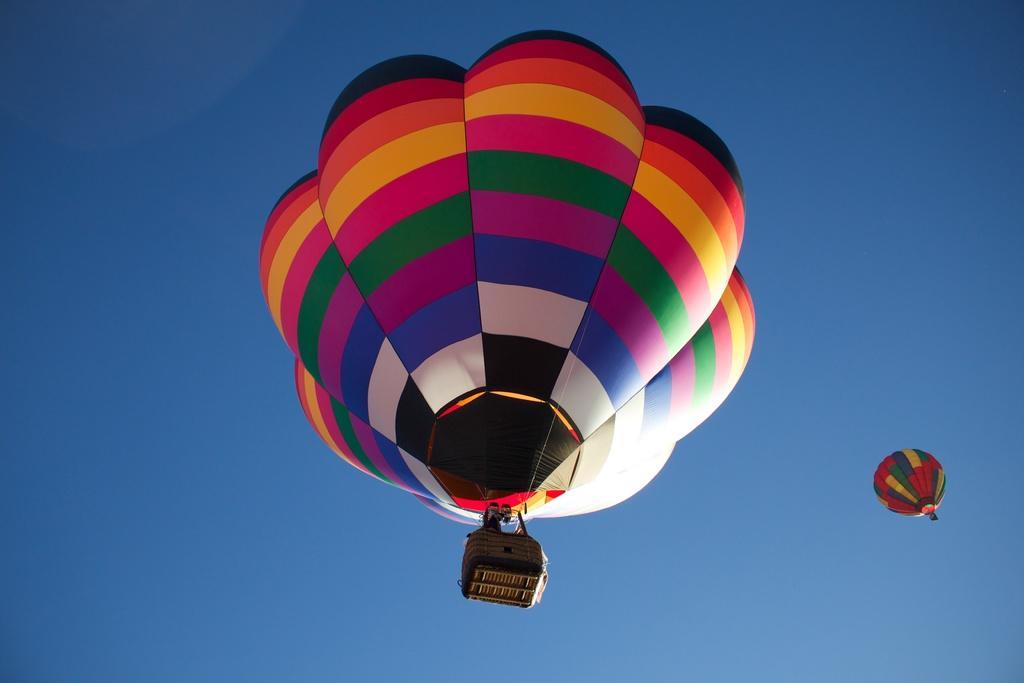Could you give a brief overview of what you see in this image? In this picture I can see are two parachutes in the sky and there are some people in the parachute. 